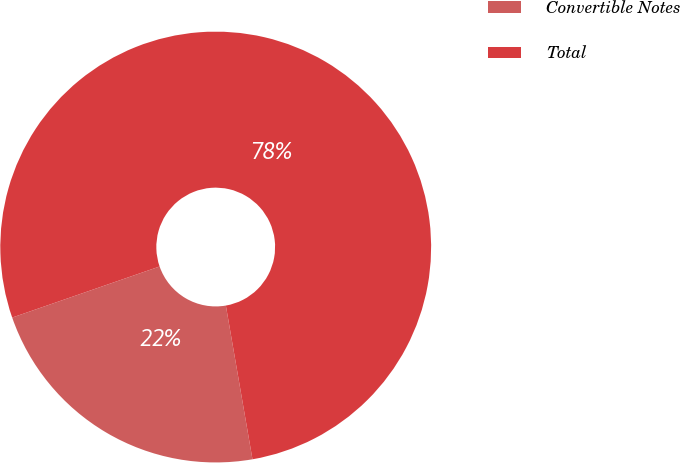Convert chart to OTSL. <chart><loc_0><loc_0><loc_500><loc_500><pie_chart><fcel>Convertible Notes<fcel>Total<nl><fcel>22.42%<fcel>77.58%<nl></chart> 